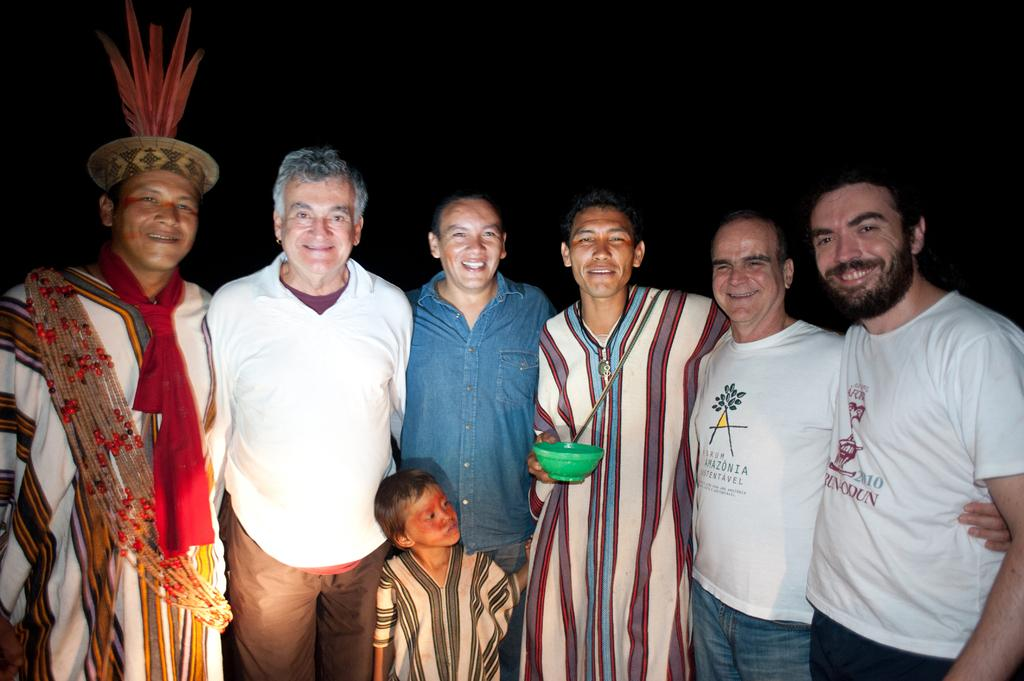What is happening in the front of the image? There is a group of people standing in the front of the image. What is one person holding in the image? One person is holding a green color bowl. How would you describe the background of the image? The background of the image is dark. What type of vest is the person wearing in the image? There is no mention of a vest in the image, so it cannot be determined if someone is wearing one. What story is being told by the group of people in the image? The image does not depict a story or any specific narrative, so it cannot be determined what story might be being told. 